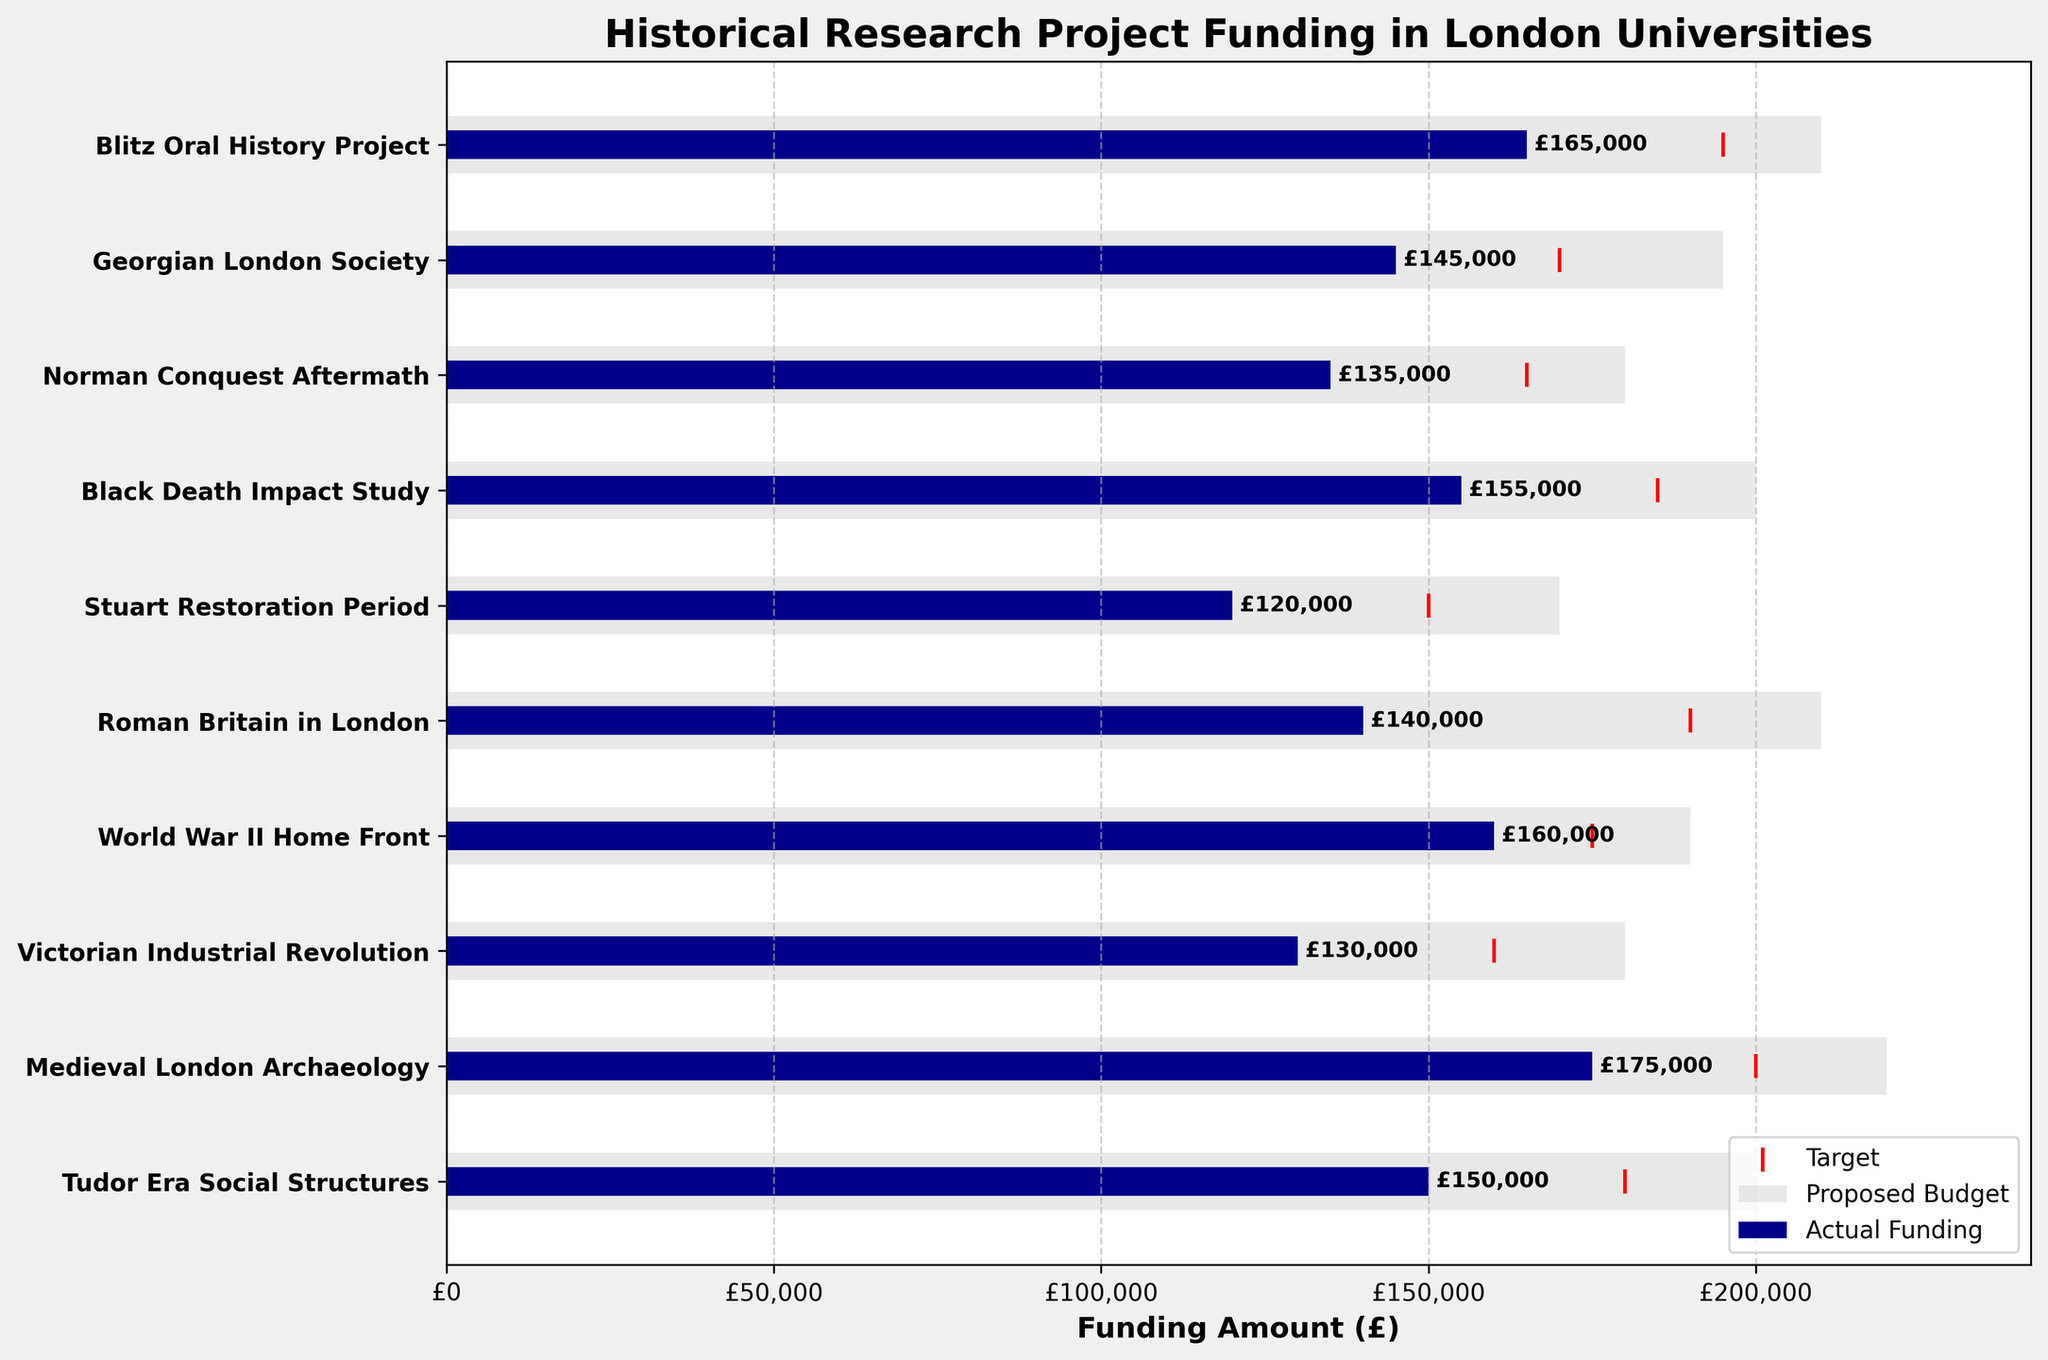What is the title of the figure? The title is usually found at the top of the chart and summarizes the main purpose or focus of the visual representation. In this case, it tells us that the chart is about funding for historical research projects in London universities.
Answer: Historical Research Project Funding in London Universities How many projects received funding below their proposed budget? We can compare the lengths of the light grey bars (proposed budgets) with the dark blue bars (actual funding). Count the number of projects where the dark blue bar is shorter than the light grey bar.
Answer: 10 Which project received the highest actual funding? By comparing the lengths of the dark blue bars (actual funding), we can identify the project with the longest dark blue bar.
Answer: Medieval London Archaeology Did any project meet their target funding exactly? Compare the positions of the red markers (target) with the end points of the dark blue bars (actual funding).
Answer: No What is the funding gap between the proposed budget and actual funding for the Roman Britain in London project? Identify the difference between the lengths of the light grey bar (proposed budget) and the dark blue bar (actual funding) for the Roman Britain in London project.
Answer: £70,000 Which project has the smallest funding gap between actual funding and the proposed budget? Calculate the funding gap for each project by subtracting the actual funding (dark blue bar) from the proposed budget (light grey bar) and find the smallest value.
Answer: World War II Home Front What's the total actual funding received by all projects combined? To find the total actual funding, sum the values of all the projects' actual funding (dark blue bars). This requires adding the actual funding for each project: 150,000 + 175,000 + 130,000 + 160,000 + 140,000 + 120,000 + 155,000 + 135,000 + 145,000 + 165,000.
Answer: £1,475,000 How does the actual funding for the Black Death Impact Study compare to its target? Compare the dark blue bar (actual funding) against the red marker (target) for the Black Death Impact Study project.
Answer: Below target by £30,000 What is the difference between the highest proposed budget and the lowest proposed budget? Identify the longest light grey bar (highest proposed budget) and the shortest light grey bar (lowest proposed budget) and calculate the difference between them.
Answer: £50,000 Which project had the highest target funding, and how much was its actual funding? Look for the highest red marker (target) and note the project associated with it, then check the corresponding dark blue bar (actual funding) value.
Answer: Blitz Oral History Project, £165,000 